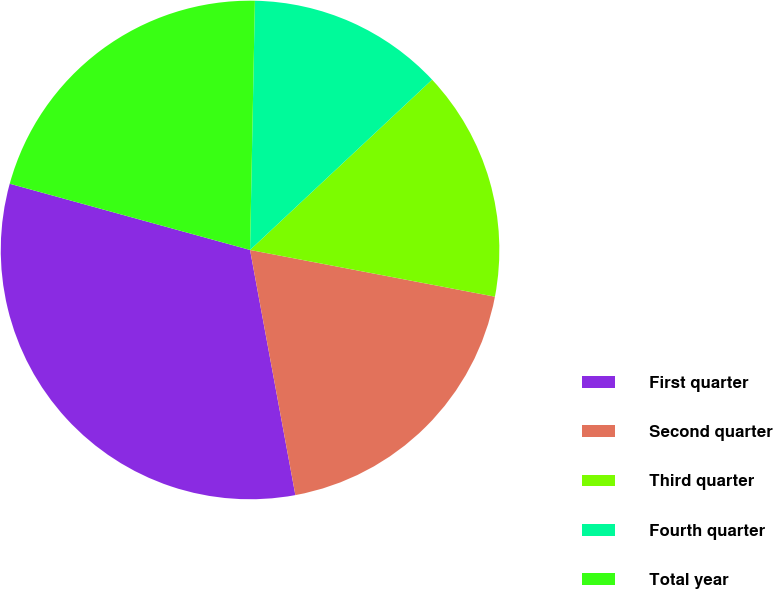Convert chart to OTSL. <chart><loc_0><loc_0><loc_500><loc_500><pie_chart><fcel>First quarter<fcel>Second quarter<fcel>Third quarter<fcel>Fourth quarter<fcel>Total year<nl><fcel>32.19%<fcel>19.09%<fcel>14.97%<fcel>12.72%<fcel>21.03%<nl></chart> 